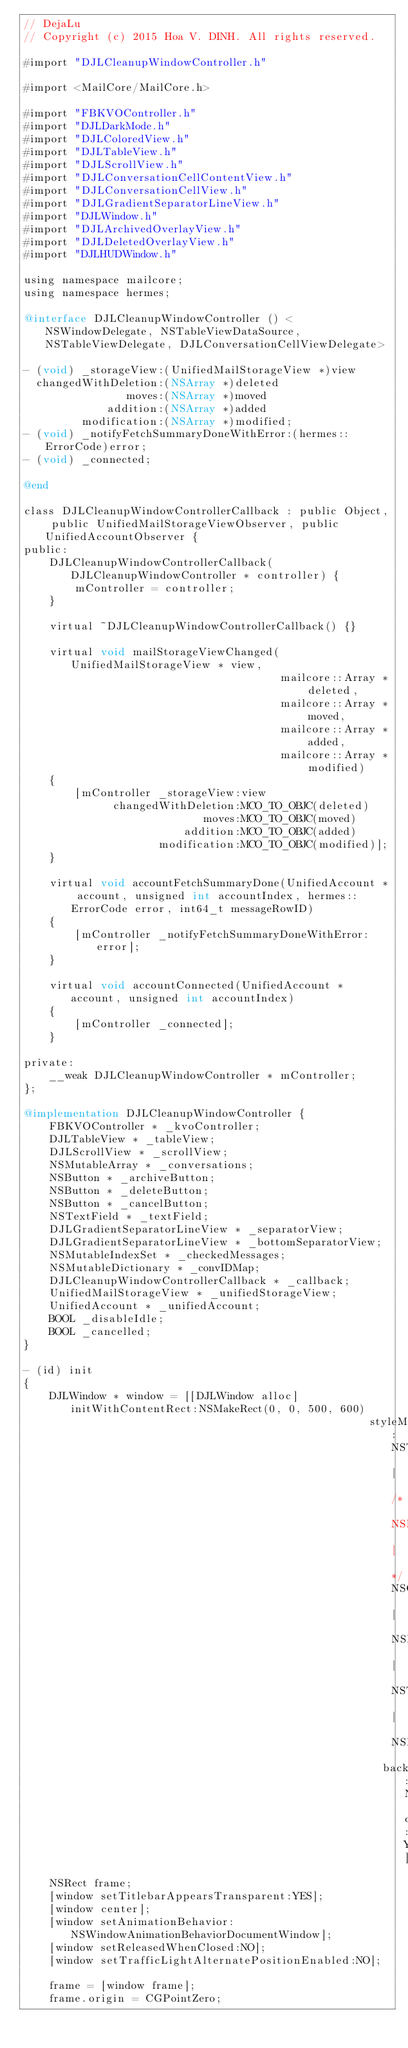Convert code to text. <code><loc_0><loc_0><loc_500><loc_500><_ObjectiveC_>// DejaLu
// Copyright (c) 2015 Hoa V. DINH. All rights reserved.

#import "DJLCleanupWindowController.h"

#import <MailCore/MailCore.h>

#import "FBKVOController.h"
#import "DJLDarkMode.h"
#import "DJLColoredView.h"
#import "DJLTableView.h"
#import "DJLScrollView.h"
#import "DJLConversationCellContentView.h"
#import "DJLConversationCellView.h"
#import "DJLGradientSeparatorLineView.h"
#import "DJLWindow.h"
#import "DJLArchivedOverlayView.h"
#import "DJLDeletedOverlayView.h"
#import "DJLHUDWindow.h"

using namespace mailcore;
using namespace hermes;

@interface DJLCleanupWindowController () <NSWindowDelegate, NSTableViewDataSource, NSTableViewDelegate, DJLConversationCellViewDelegate>

- (void) _storageView:(UnifiedMailStorageView *)view
  changedWithDeletion:(NSArray *)deleted
                moves:(NSArray *)moved
             addition:(NSArray *)added
         modification:(NSArray *)modified;
- (void) _notifyFetchSummaryDoneWithError:(hermes::ErrorCode)error;
- (void) _connected;

@end

class DJLCleanupWindowControllerCallback : public Object, public UnifiedMailStorageViewObserver, public UnifiedAccountObserver {
public:
    DJLCleanupWindowControllerCallback(DJLCleanupWindowController * controller) {
        mController = controller;
    }

    virtual ~DJLCleanupWindowControllerCallback() {}

    virtual void mailStorageViewChanged(UnifiedMailStorageView * view,
                                        mailcore::Array * deleted,
                                        mailcore::Array * moved,
                                        mailcore::Array * added,
                                        mailcore::Array * modified)
    {
        [mController _storageView:view
              changedWithDeletion:MCO_TO_OBJC(deleted)
                            moves:MCO_TO_OBJC(moved)
                         addition:MCO_TO_OBJC(added)
                     modification:MCO_TO_OBJC(modified)];
    }

    virtual void accountFetchSummaryDone(UnifiedAccount * account, unsigned int accountIndex, hermes::ErrorCode error, int64_t messageRowID)
    {
        [mController _notifyFetchSummaryDoneWithError:error];
    }

    virtual void accountConnected(UnifiedAccount * account, unsigned int accountIndex)
    {
        [mController _connected];
    }

private:
    __weak DJLCleanupWindowController * mController;
};

@implementation DJLCleanupWindowController {
    FBKVOController * _kvoController;
    DJLTableView * _tableView;
    DJLScrollView * _scrollView;
    NSMutableArray * _conversations;
    NSButton * _archiveButton;
    NSButton * _deleteButton;
    NSButton * _cancelButton;
    NSTextField * _textField;
    DJLGradientSeparatorLineView * _separatorView;
    DJLGradientSeparatorLineView * _bottomSeparatorView;
    NSMutableIndexSet * _checkedMessages;
    NSMutableDictionary * _convIDMap;
    DJLCleanupWindowControllerCallback * _callback;
    UnifiedMailStorageView * _unifiedStorageView;
    UnifiedAccount * _unifiedAccount;
    BOOL _disableIdle;
    BOOL _cancelled;
}

- (id) init
{
    DJLWindow * window = [[DJLWindow alloc] initWithContentRect:NSMakeRect(0, 0, 500, 600)
                                                      styleMask:NSTitledWindowMask | /* NSResizableWindowMask | */NSClosableWindowMask | NSMiniaturizableWindowMask | NSTexturedBackgroundWindowMask | NSFullSizeContentViewWindowMask
                                                        backing:NSBackingStoreBuffered defer:YES];
    NSRect frame;
    [window setTitlebarAppearsTransparent:YES];
    [window center];
    [window setAnimationBehavior:NSWindowAnimationBehaviorDocumentWindow];
    [window setReleasedWhenClosed:NO];
    [window setTrafficLightAlternatePositionEnabled:NO];

    frame = [window frame];
    frame.origin = CGPointZero;</code> 